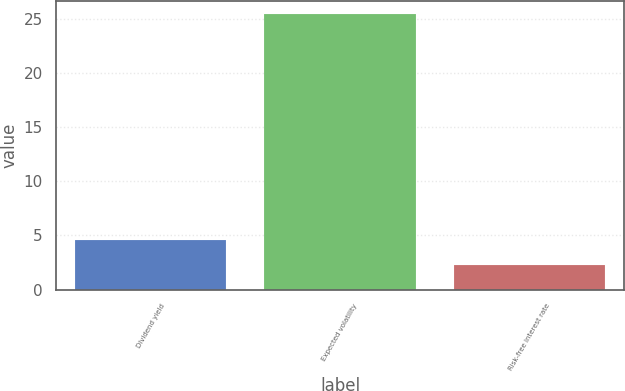Convert chart. <chart><loc_0><loc_0><loc_500><loc_500><bar_chart><fcel>Dividend yield<fcel>Expected volatility<fcel>Risk-free interest rate<nl><fcel>4.61<fcel>25.4<fcel>2.3<nl></chart> 